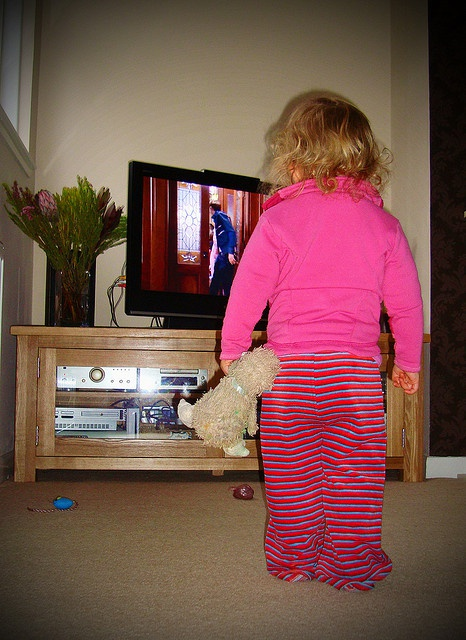Describe the objects in this image and their specific colors. I can see people in black, violet, red, and brown tones, tv in black, maroon, lavender, and navy tones, potted plant in black, olive, maroon, and tan tones, teddy bear in black and tan tones, and people in black, navy, darkblue, and lightpink tones in this image. 